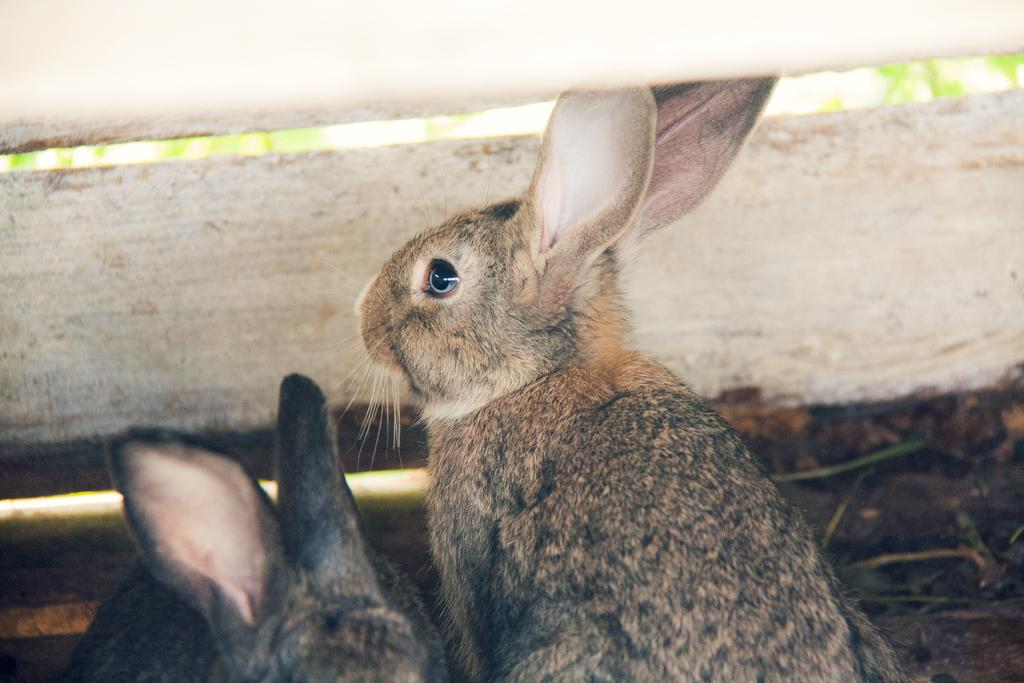What animals are present in the image? There are rabbits in the image. Can you describe the background of the image? The background of the image is blurry. Where are the flowers located in the image? There are no flowers present in the image. What part of the rabbit's body is visible in the image? The image does not show any specific part of the rabbit's body, as it is focused on the rabbits themselves and not their individual body parts. 